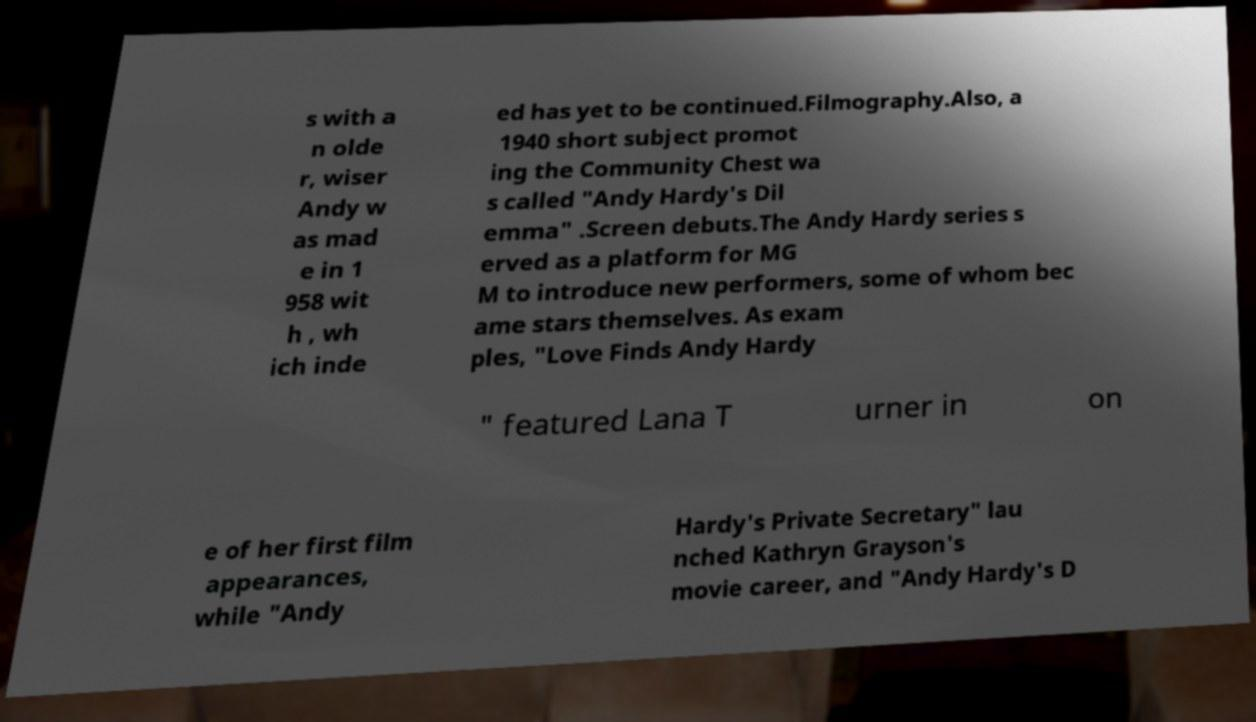Can you read and provide the text displayed in the image?This photo seems to have some interesting text. Can you extract and type it out for me? s with a n olde r, wiser Andy w as mad e in 1 958 wit h , wh ich inde ed has yet to be continued.Filmography.Also, a 1940 short subject promot ing the Community Chest wa s called "Andy Hardy's Dil emma" .Screen debuts.The Andy Hardy series s erved as a platform for MG M to introduce new performers, some of whom bec ame stars themselves. As exam ples, "Love Finds Andy Hardy " featured Lana T urner in on e of her first film appearances, while "Andy Hardy's Private Secretary" lau nched Kathryn Grayson's movie career, and "Andy Hardy's D 